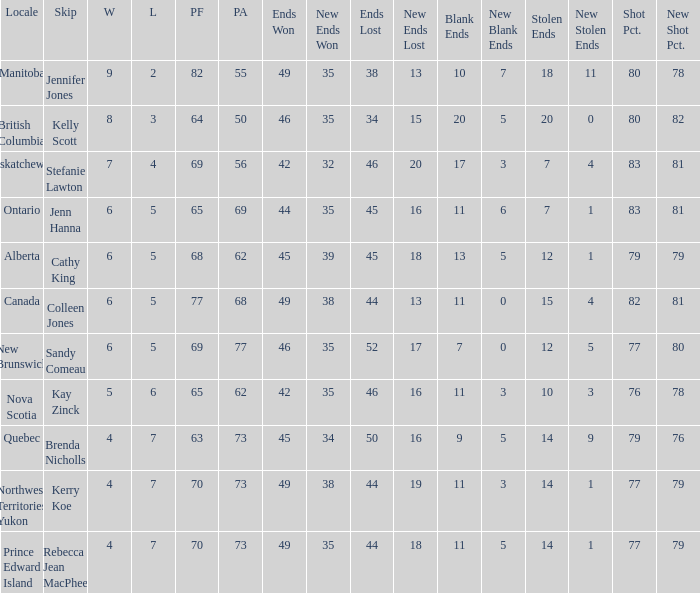What is the PA when the skip is Colleen Jones? 68.0. 